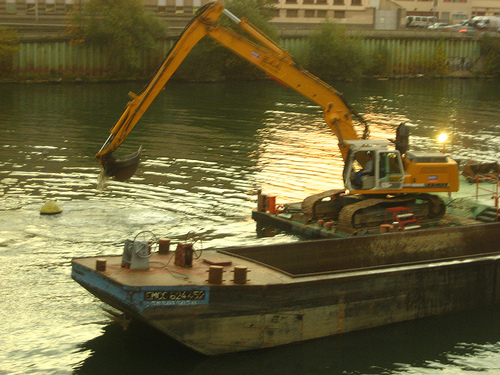<image>
Can you confirm if the crane is on the water? Yes. Looking at the image, I can see the crane is positioned on top of the water, with the water providing support. 